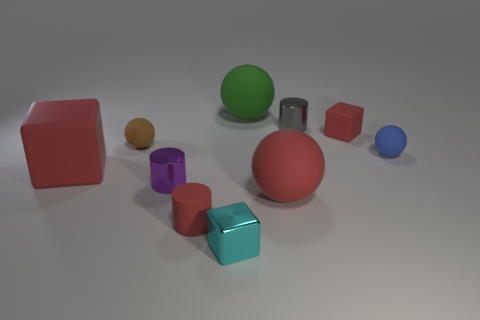Subtract all spheres. How many objects are left? 6 Subtract 0 yellow balls. How many objects are left? 10 Subtract all red metal things. Subtract all big red matte cubes. How many objects are left? 9 Add 2 small gray metallic things. How many small gray metallic things are left? 3 Add 8 tiny purple metal things. How many tiny purple metal things exist? 9 